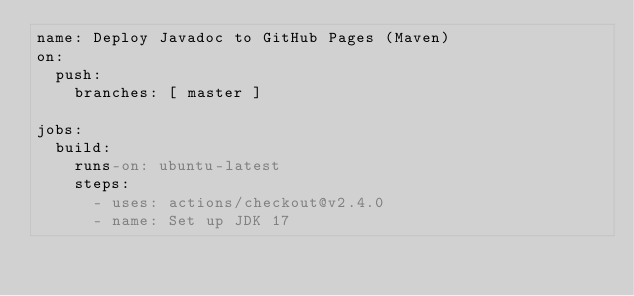Convert code to text. <code><loc_0><loc_0><loc_500><loc_500><_YAML_>name: Deploy Javadoc to GitHub Pages (Maven)
on:
  push:
    branches: [ master ]

jobs:
  build:
    runs-on: ubuntu-latest
    steps:
      - uses: actions/checkout@v2.4.0
      - name: Set up JDK 17</code> 